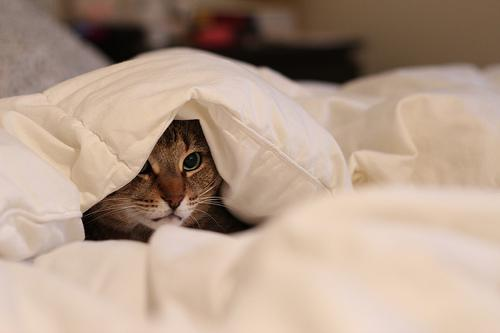Question: where was the photo taken?
Choices:
A. On a sofa.
B. On a sleeping bag.
C. On a bed.
D. On a chair.
Answer with the letter. Answer: C 